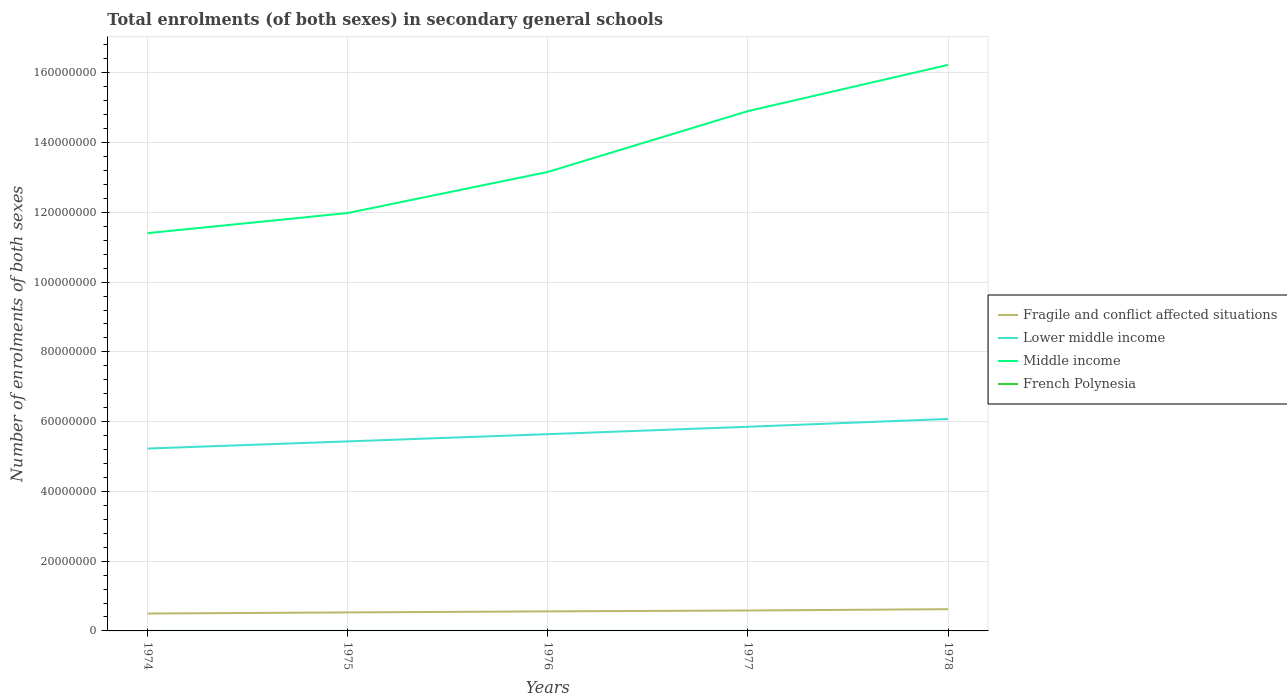Does the line corresponding to French Polynesia intersect with the line corresponding to Lower middle income?
Provide a short and direct response. No. Is the number of lines equal to the number of legend labels?
Your response must be concise. Yes. Across all years, what is the maximum number of enrolments in secondary schools in Middle income?
Keep it short and to the point. 1.14e+08. In which year was the number of enrolments in secondary schools in Fragile and conflict affected situations maximum?
Your response must be concise. 1974. What is the total number of enrolments in secondary schools in French Polynesia in the graph?
Provide a succinct answer. -234. What is the difference between the highest and the second highest number of enrolments in secondary schools in Lower middle income?
Provide a short and direct response. 8.49e+06. What is the difference between the highest and the lowest number of enrolments in secondary schools in Lower middle income?
Provide a succinct answer. 2. Is the number of enrolments in secondary schools in Middle income strictly greater than the number of enrolments in secondary schools in French Polynesia over the years?
Your response must be concise. No. How many lines are there?
Keep it short and to the point. 4. Are the values on the major ticks of Y-axis written in scientific E-notation?
Your response must be concise. No. Does the graph contain any zero values?
Ensure brevity in your answer.  No. Does the graph contain grids?
Provide a short and direct response. Yes. Where does the legend appear in the graph?
Offer a terse response. Center right. How many legend labels are there?
Ensure brevity in your answer.  4. What is the title of the graph?
Give a very brief answer. Total enrolments (of both sexes) in secondary general schools. Does "Korea (Democratic)" appear as one of the legend labels in the graph?
Offer a terse response. No. What is the label or title of the X-axis?
Give a very brief answer. Years. What is the label or title of the Y-axis?
Your answer should be compact. Number of enrolments of both sexes. What is the Number of enrolments of both sexes in Fragile and conflict affected situations in 1974?
Keep it short and to the point. 4.98e+06. What is the Number of enrolments of both sexes in Lower middle income in 1974?
Provide a succinct answer. 5.23e+07. What is the Number of enrolments of both sexes of Middle income in 1974?
Ensure brevity in your answer.  1.14e+08. What is the Number of enrolments of both sexes in French Polynesia in 1974?
Offer a terse response. 6597. What is the Number of enrolments of both sexes in Fragile and conflict affected situations in 1975?
Provide a short and direct response. 5.31e+06. What is the Number of enrolments of both sexes of Lower middle income in 1975?
Provide a short and direct response. 5.43e+07. What is the Number of enrolments of both sexes in Middle income in 1975?
Give a very brief answer. 1.20e+08. What is the Number of enrolments of both sexes of French Polynesia in 1975?
Make the answer very short. 7046. What is the Number of enrolments of both sexes in Fragile and conflict affected situations in 1976?
Offer a very short reply. 5.60e+06. What is the Number of enrolments of both sexes in Lower middle income in 1976?
Your response must be concise. 5.64e+07. What is the Number of enrolments of both sexes in Middle income in 1976?
Your answer should be compact. 1.32e+08. What is the Number of enrolments of both sexes of French Polynesia in 1976?
Give a very brief answer. 7280. What is the Number of enrolments of both sexes of Fragile and conflict affected situations in 1977?
Keep it short and to the point. 5.85e+06. What is the Number of enrolments of both sexes of Lower middle income in 1977?
Provide a short and direct response. 5.85e+07. What is the Number of enrolments of both sexes of Middle income in 1977?
Make the answer very short. 1.49e+08. What is the Number of enrolments of both sexes of French Polynesia in 1977?
Provide a succinct answer. 7727. What is the Number of enrolments of both sexes of Fragile and conflict affected situations in 1978?
Your answer should be compact. 6.23e+06. What is the Number of enrolments of both sexes in Lower middle income in 1978?
Offer a very short reply. 6.08e+07. What is the Number of enrolments of both sexes of Middle income in 1978?
Your answer should be very brief. 1.62e+08. What is the Number of enrolments of both sexes of French Polynesia in 1978?
Make the answer very short. 8047. Across all years, what is the maximum Number of enrolments of both sexes of Fragile and conflict affected situations?
Keep it short and to the point. 6.23e+06. Across all years, what is the maximum Number of enrolments of both sexes of Lower middle income?
Your answer should be very brief. 6.08e+07. Across all years, what is the maximum Number of enrolments of both sexes in Middle income?
Make the answer very short. 1.62e+08. Across all years, what is the maximum Number of enrolments of both sexes in French Polynesia?
Your answer should be compact. 8047. Across all years, what is the minimum Number of enrolments of both sexes in Fragile and conflict affected situations?
Keep it short and to the point. 4.98e+06. Across all years, what is the minimum Number of enrolments of both sexes of Lower middle income?
Offer a very short reply. 5.23e+07. Across all years, what is the minimum Number of enrolments of both sexes in Middle income?
Make the answer very short. 1.14e+08. Across all years, what is the minimum Number of enrolments of both sexes in French Polynesia?
Your response must be concise. 6597. What is the total Number of enrolments of both sexes in Fragile and conflict affected situations in the graph?
Offer a very short reply. 2.80e+07. What is the total Number of enrolments of both sexes in Lower middle income in the graph?
Ensure brevity in your answer.  2.82e+08. What is the total Number of enrolments of both sexes of Middle income in the graph?
Provide a short and direct response. 6.77e+08. What is the total Number of enrolments of both sexes of French Polynesia in the graph?
Give a very brief answer. 3.67e+04. What is the difference between the Number of enrolments of both sexes in Fragile and conflict affected situations in 1974 and that in 1975?
Give a very brief answer. -3.22e+05. What is the difference between the Number of enrolments of both sexes in Lower middle income in 1974 and that in 1975?
Provide a succinct answer. -2.05e+06. What is the difference between the Number of enrolments of both sexes of Middle income in 1974 and that in 1975?
Your answer should be very brief. -5.76e+06. What is the difference between the Number of enrolments of both sexes in French Polynesia in 1974 and that in 1975?
Ensure brevity in your answer.  -449. What is the difference between the Number of enrolments of both sexes in Fragile and conflict affected situations in 1974 and that in 1976?
Keep it short and to the point. -6.21e+05. What is the difference between the Number of enrolments of both sexes in Lower middle income in 1974 and that in 1976?
Your response must be concise. -4.12e+06. What is the difference between the Number of enrolments of both sexes in Middle income in 1974 and that in 1976?
Make the answer very short. -1.75e+07. What is the difference between the Number of enrolments of both sexes of French Polynesia in 1974 and that in 1976?
Your answer should be very brief. -683. What is the difference between the Number of enrolments of both sexes in Fragile and conflict affected situations in 1974 and that in 1977?
Offer a terse response. -8.71e+05. What is the difference between the Number of enrolments of both sexes in Lower middle income in 1974 and that in 1977?
Offer a terse response. -6.24e+06. What is the difference between the Number of enrolments of both sexes of Middle income in 1974 and that in 1977?
Offer a terse response. -3.50e+07. What is the difference between the Number of enrolments of both sexes of French Polynesia in 1974 and that in 1977?
Provide a short and direct response. -1130. What is the difference between the Number of enrolments of both sexes in Fragile and conflict affected situations in 1974 and that in 1978?
Make the answer very short. -1.25e+06. What is the difference between the Number of enrolments of both sexes in Lower middle income in 1974 and that in 1978?
Provide a short and direct response. -8.49e+06. What is the difference between the Number of enrolments of both sexes in Middle income in 1974 and that in 1978?
Offer a very short reply. -4.82e+07. What is the difference between the Number of enrolments of both sexes in French Polynesia in 1974 and that in 1978?
Ensure brevity in your answer.  -1450. What is the difference between the Number of enrolments of both sexes of Fragile and conflict affected situations in 1975 and that in 1976?
Your answer should be very brief. -2.99e+05. What is the difference between the Number of enrolments of both sexes in Lower middle income in 1975 and that in 1976?
Your answer should be very brief. -2.07e+06. What is the difference between the Number of enrolments of both sexes in Middle income in 1975 and that in 1976?
Provide a short and direct response. -1.18e+07. What is the difference between the Number of enrolments of both sexes of French Polynesia in 1975 and that in 1976?
Your answer should be compact. -234. What is the difference between the Number of enrolments of both sexes of Fragile and conflict affected situations in 1975 and that in 1977?
Ensure brevity in your answer.  -5.49e+05. What is the difference between the Number of enrolments of both sexes of Lower middle income in 1975 and that in 1977?
Ensure brevity in your answer.  -4.19e+06. What is the difference between the Number of enrolments of both sexes in Middle income in 1975 and that in 1977?
Provide a short and direct response. -2.92e+07. What is the difference between the Number of enrolments of both sexes of French Polynesia in 1975 and that in 1977?
Provide a succinct answer. -681. What is the difference between the Number of enrolments of both sexes in Fragile and conflict affected situations in 1975 and that in 1978?
Give a very brief answer. -9.24e+05. What is the difference between the Number of enrolments of both sexes of Lower middle income in 1975 and that in 1978?
Give a very brief answer. -6.44e+06. What is the difference between the Number of enrolments of both sexes of Middle income in 1975 and that in 1978?
Your answer should be very brief. -4.25e+07. What is the difference between the Number of enrolments of both sexes of French Polynesia in 1975 and that in 1978?
Your answer should be very brief. -1001. What is the difference between the Number of enrolments of both sexes in Fragile and conflict affected situations in 1976 and that in 1977?
Ensure brevity in your answer.  -2.49e+05. What is the difference between the Number of enrolments of both sexes of Lower middle income in 1976 and that in 1977?
Your response must be concise. -2.12e+06. What is the difference between the Number of enrolments of both sexes in Middle income in 1976 and that in 1977?
Ensure brevity in your answer.  -1.74e+07. What is the difference between the Number of enrolments of both sexes of French Polynesia in 1976 and that in 1977?
Offer a very short reply. -447. What is the difference between the Number of enrolments of both sexes of Fragile and conflict affected situations in 1976 and that in 1978?
Provide a succinct answer. -6.24e+05. What is the difference between the Number of enrolments of both sexes in Lower middle income in 1976 and that in 1978?
Provide a short and direct response. -4.37e+06. What is the difference between the Number of enrolments of both sexes of Middle income in 1976 and that in 1978?
Ensure brevity in your answer.  -3.07e+07. What is the difference between the Number of enrolments of both sexes in French Polynesia in 1976 and that in 1978?
Provide a short and direct response. -767. What is the difference between the Number of enrolments of both sexes in Fragile and conflict affected situations in 1977 and that in 1978?
Provide a succinct answer. -3.75e+05. What is the difference between the Number of enrolments of both sexes of Lower middle income in 1977 and that in 1978?
Provide a short and direct response. -2.25e+06. What is the difference between the Number of enrolments of both sexes in Middle income in 1977 and that in 1978?
Provide a succinct answer. -1.32e+07. What is the difference between the Number of enrolments of both sexes in French Polynesia in 1977 and that in 1978?
Ensure brevity in your answer.  -320. What is the difference between the Number of enrolments of both sexes of Fragile and conflict affected situations in 1974 and the Number of enrolments of both sexes of Lower middle income in 1975?
Provide a short and direct response. -4.94e+07. What is the difference between the Number of enrolments of both sexes in Fragile and conflict affected situations in 1974 and the Number of enrolments of both sexes in Middle income in 1975?
Offer a very short reply. -1.15e+08. What is the difference between the Number of enrolments of both sexes of Fragile and conflict affected situations in 1974 and the Number of enrolments of both sexes of French Polynesia in 1975?
Keep it short and to the point. 4.98e+06. What is the difference between the Number of enrolments of both sexes in Lower middle income in 1974 and the Number of enrolments of both sexes in Middle income in 1975?
Give a very brief answer. -6.75e+07. What is the difference between the Number of enrolments of both sexes of Lower middle income in 1974 and the Number of enrolments of both sexes of French Polynesia in 1975?
Offer a terse response. 5.23e+07. What is the difference between the Number of enrolments of both sexes of Middle income in 1974 and the Number of enrolments of both sexes of French Polynesia in 1975?
Provide a short and direct response. 1.14e+08. What is the difference between the Number of enrolments of both sexes in Fragile and conflict affected situations in 1974 and the Number of enrolments of both sexes in Lower middle income in 1976?
Your answer should be compact. -5.14e+07. What is the difference between the Number of enrolments of both sexes in Fragile and conflict affected situations in 1974 and the Number of enrolments of both sexes in Middle income in 1976?
Make the answer very short. -1.27e+08. What is the difference between the Number of enrolments of both sexes of Fragile and conflict affected situations in 1974 and the Number of enrolments of both sexes of French Polynesia in 1976?
Offer a terse response. 4.98e+06. What is the difference between the Number of enrolments of both sexes of Lower middle income in 1974 and the Number of enrolments of both sexes of Middle income in 1976?
Ensure brevity in your answer.  -7.93e+07. What is the difference between the Number of enrolments of both sexes in Lower middle income in 1974 and the Number of enrolments of both sexes in French Polynesia in 1976?
Keep it short and to the point. 5.23e+07. What is the difference between the Number of enrolments of both sexes in Middle income in 1974 and the Number of enrolments of both sexes in French Polynesia in 1976?
Provide a short and direct response. 1.14e+08. What is the difference between the Number of enrolments of both sexes of Fragile and conflict affected situations in 1974 and the Number of enrolments of both sexes of Lower middle income in 1977?
Provide a succinct answer. -5.35e+07. What is the difference between the Number of enrolments of both sexes in Fragile and conflict affected situations in 1974 and the Number of enrolments of both sexes in Middle income in 1977?
Give a very brief answer. -1.44e+08. What is the difference between the Number of enrolments of both sexes in Fragile and conflict affected situations in 1974 and the Number of enrolments of both sexes in French Polynesia in 1977?
Offer a terse response. 4.98e+06. What is the difference between the Number of enrolments of both sexes of Lower middle income in 1974 and the Number of enrolments of both sexes of Middle income in 1977?
Give a very brief answer. -9.67e+07. What is the difference between the Number of enrolments of both sexes in Lower middle income in 1974 and the Number of enrolments of both sexes in French Polynesia in 1977?
Give a very brief answer. 5.23e+07. What is the difference between the Number of enrolments of both sexes of Middle income in 1974 and the Number of enrolments of both sexes of French Polynesia in 1977?
Your answer should be compact. 1.14e+08. What is the difference between the Number of enrolments of both sexes of Fragile and conflict affected situations in 1974 and the Number of enrolments of both sexes of Lower middle income in 1978?
Your answer should be compact. -5.58e+07. What is the difference between the Number of enrolments of both sexes of Fragile and conflict affected situations in 1974 and the Number of enrolments of both sexes of Middle income in 1978?
Give a very brief answer. -1.57e+08. What is the difference between the Number of enrolments of both sexes of Fragile and conflict affected situations in 1974 and the Number of enrolments of both sexes of French Polynesia in 1978?
Offer a terse response. 4.98e+06. What is the difference between the Number of enrolments of both sexes in Lower middle income in 1974 and the Number of enrolments of both sexes in Middle income in 1978?
Provide a succinct answer. -1.10e+08. What is the difference between the Number of enrolments of both sexes of Lower middle income in 1974 and the Number of enrolments of both sexes of French Polynesia in 1978?
Provide a short and direct response. 5.23e+07. What is the difference between the Number of enrolments of both sexes of Middle income in 1974 and the Number of enrolments of both sexes of French Polynesia in 1978?
Give a very brief answer. 1.14e+08. What is the difference between the Number of enrolments of both sexes in Fragile and conflict affected situations in 1975 and the Number of enrolments of both sexes in Lower middle income in 1976?
Your answer should be very brief. -5.11e+07. What is the difference between the Number of enrolments of both sexes of Fragile and conflict affected situations in 1975 and the Number of enrolments of both sexes of Middle income in 1976?
Make the answer very short. -1.26e+08. What is the difference between the Number of enrolments of both sexes of Fragile and conflict affected situations in 1975 and the Number of enrolments of both sexes of French Polynesia in 1976?
Your response must be concise. 5.30e+06. What is the difference between the Number of enrolments of both sexes of Lower middle income in 1975 and the Number of enrolments of both sexes of Middle income in 1976?
Provide a short and direct response. -7.73e+07. What is the difference between the Number of enrolments of both sexes in Lower middle income in 1975 and the Number of enrolments of both sexes in French Polynesia in 1976?
Your answer should be compact. 5.43e+07. What is the difference between the Number of enrolments of both sexes of Middle income in 1975 and the Number of enrolments of both sexes of French Polynesia in 1976?
Provide a succinct answer. 1.20e+08. What is the difference between the Number of enrolments of both sexes in Fragile and conflict affected situations in 1975 and the Number of enrolments of both sexes in Lower middle income in 1977?
Offer a very short reply. -5.32e+07. What is the difference between the Number of enrolments of both sexes in Fragile and conflict affected situations in 1975 and the Number of enrolments of both sexes in Middle income in 1977?
Offer a terse response. -1.44e+08. What is the difference between the Number of enrolments of both sexes of Fragile and conflict affected situations in 1975 and the Number of enrolments of both sexes of French Polynesia in 1977?
Your answer should be compact. 5.30e+06. What is the difference between the Number of enrolments of both sexes in Lower middle income in 1975 and the Number of enrolments of both sexes in Middle income in 1977?
Give a very brief answer. -9.47e+07. What is the difference between the Number of enrolments of both sexes in Lower middle income in 1975 and the Number of enrolments of both sexes in French Polynesia in 1977?
Offer a very short reply. 5.43e+07. What is the difference between the Number of enrolments of both sexes of Middle income in 1975 and the Number of enrolments of both sexes of French Polynesia in 1977?
Make the answer very short. 1.20e+08. What is the difference between the Number of enrolments of both sexes in Fragile and conflict affected situations in 1975 and the Number of enrolments of both sexes in Lower middle income in 1978?
Provide a short and direct response. -5.55e+07. What is the difference between the Number of enrolments of both sexes in Fragile and conflict affected situations in 1975 and the Number of enrolments of both sexes in Middle income in 1978?
Offer a terse response. -1.57e+08. What is the difference between the Number of enrolments of both sexes of Fragile and conflict affected situations in 1975 and the Number of enrolments of both sexes of French Polynesia in 1978?
Offer a terse response. 5.30e+06. What is the difference between the Number of enrolments of both sexes of Lower middle income in 1975 and the Number of enrolments of both sexes of Middle income in 1978?
Your answer should be compact. -1.08e+08. What is the difference between the Number of enrolments of both sexes in Lower middle income in 1975 and the Number of enrolments of both sexes in French Polynesia in 1978?
Keep it short and to the point. 5.43e+07. What is the difference between the Number of enrolments of both sexes in Middle income in 1975 and the Number of enrolments of both sexes in French Polynesia in 1978?
Provide a short and direct response. 1.20e+08. What is the difference between the Number of enrolments of both sexes in Fragile and conflict affected situations in 1976 and the Number of enrolments of both sexes in Lower middle income in 1977?
Your response must be concise. -5.29e+07. What is the difference between the Number of enrolments of both sexes of Fragile and conflict affected situations in 1976 and the Number of enrolments of both sexes of Middle income in 1977?
Your answer should be compact. -1.43e+08. What is the difference between the Number of enrolments of both sexes of Fragile and conflict affected situations in 1976 and the Number of enrolments of both sexes of French Polynesia in 1977?
Provide a succinct answer. 5.60e+06. What is the difference between the Number of enrolments of both sexes in Lower middle income in 1976 and the Number of enrolments of both sexes in Middle income in 1977?
Give a very brief answer. -9.26e+07. What is the difference between the Number of enrolments of both sexes of Lower middle income in 1976 and the Number of enrolments of both sexes of French Polynesia in 1977?
Your response must be concise. 5.64e+07. What is the difference between the Number of enrolments of both sexes in Middle income in 1976 and the Number of enrolments of both sexes in French Polynesia in 1977?
Your response must be concise. 1.32e+08. What is the difference between the Number of enrolments of both sexes in Fragile and conflict affected situations in 1976 and the Number of enrolments of both sexes in Lower middle income in 1978?
Your response must be concise. -5.52e+07. What is the difference between the Number of enrolments of both sexes in Fragile and conflict affected situations in 1976 and the Number of enrolments of both sexes in Middle income in 1978?
Provide a short and direct response. -1.57e+08. What is the difference between the Number of enrolments of both sexes in Fragile and conflict affected situations in 1976 and the Number of enrolments of both sexes in French Polynesia in 1978?
Offer a terse response. 5.60e+06. What is the difference between the Number of enrolments of both sexes in Lower middle income in 1976 and the Number of enrolments of both sexes in Middle income in 1978?
Ensure brevity in your answer.  -1.06e+08. What is the difference between the Number of enrolments of both sexes of Lower middle income in 1976 and the Number of enrolments of both sexes of French Polynesia in 1978?
Give a very brief answer. 5.64e+07. What is the difference between the Number of enrolments of both sexes in Middle income in 1976 and the Number of enrolments of both sexes in French Polynesia in 1978?
Your answer should be very brief. 1.32e+08. What is the difference between the Number of enrolments of both sexes of Fragile and conflict affected situations in 1977 and the Number of enrolments of both sexes of Lower middle income in 1978?
Make the answer very short. -5.49e+07. What is the difference between the Number of enrolments of both sexes of Fragile and conflict affected situations in 1977 and the Number of enrolments of both sexes of Middle income in 1978?
Ensure brevity in your answer.  -1.56e+08. What is the difference between the Number of enrolments of both sexes in Fragile and conflict affected situations in 1977 and the Number of enrolments of both sexes in French Polynesia in 1978?
Offer a terse response. 5.85e+06. What is the difference between the Number of enrolments of both sexes in Lower middle income in 1977 and the Number of enrolments of both sexes in Middle income in 1978?
Provide a succinct answer. -1.04e+08. What is the difference between the Number of enrolments of both sexes of Lower middle income in 1977 and the Number of enrolments of both sexes of French Polynesia in 1978?
Make the answer very short. 5.85e+07. What is the difference between the Number of enrolments of both sexes of Middle income in 1977 and the Number of enrolments of both sexes of French Polynesia in 1978?
Ensure brevity in your answer.  1.49e+08. What is the average Number of enrolments of both sexes in Fragile and conflict affected situations per year?
Your answer should be compact. 5.60e+06. What is the average Number of enrolments of both sexes in Lower middle income per year?
Your answer should be compact. 5.65e+07. What is the average Number of enrolments of both sexes of Middle income per year?
Your answer should be very brief. 1.35e+08. What is the average Number of enrolments of both sexes in French Polynesia per year?
Keep it short and to the point. 7339.4. In the year 1974, what is the difference between the Number of enrolments of both sexes in Fragile and conflict affected situations and Number of enrolments of both sexes in Lower middle income?
Provide a succinct answer. -4.73e+07. In the year 1974, what is the difference between the Number of enrolments of both sexes of Fragile and conflict affected situations and Number of enrolments of both sexes of Middle income?
Provide a short and direct response. -1.09e+08. In the year 1974, what is the difference between the Number of enrolments of both sexes of Fragile and conflict affected situations and Number of enrolments of both sexes of French Polynesia?
Your answer should be very brief. 4.98e+06. In the year 1974, what is the difference between the Number of enrolments of both sexes in Lower middle income and Number of enrolments of both sexes in Middle income?
Keep it short and to the point. -6.18e+07. In the year 1974, what is the difference between the Number of enrolments of both sexes in Lower middle income and Number of enrolments of both sexes in French Polynesia?
Provide a succinct answer. 5.23e+07. In the year 1974, what is the difference between the Number of enrolments of both sexes in Middle income and Number of enrolments of both sexes in French Polynesia?
Offer a terse response. 1.14e+08. In the year 1975, what is the difference between the Number of enrolments of both sexes in Fragile and conflict affected situations and Number of enrolments of both sexes in Lower middle income?
Your answer should be compact. -4.90e+07. In the year 1975, what is the difference between the Number of enrolments of both sexes of Fragile and conflict affected situations and Number of enrolments of both sexes of Middle income?
Give a very brief answer. -1.15e+08. In the year 1975, what is the difference between the Number of enrolments of both sexes of Fragile and conflict affected situations and Number of enrolments of both sexes of French Polynesia?
Your answer should be compact. 5.30e+06. In the year 1975, what is the difference between the Number of enrolments of both sexes of Lower middle income and Number of enrolments of both sexes of Middle income?
Keep it short and to the point. -6.55e+07. In the year 1975, what is the difference between the Number of enrolments of both sexes of Lower middle income and Number of enrolments of both sexes of French Polynesia?
Make the answer very short. 5.43e+07. In the year 1975, what is the difference between the Number of enrolments of both sexes of Middle income and Number of enrolments of both sexes of French Polynesia?
Offer a very short reply. 1.20e+08. In the year 1976, what is the difference between the Number of enrolments of both sexes of Fragile and conflict affected situations and Number of enrolments of both sexes of Lower middle income?
Your response must be concise. -5.08e+07. In the year 1976, what is the difference between the Number of enrolments of both sexes in Fragile and conflict affected situations and Number of enrolments of both sexes in Middle income?
Offer a terse response. -1.26e+08. In the year 1976, what is the difference between the Number of enrolments of both sexes in Fragile and conflict affected situations and Number of enrolments of both sexes in French Polynesia?
Offer a terse response. 5.60e+06. In the year 1976, what is the difference between the Number of enrolments of both sexes in Lower middle income and Number of enrolments of both sexes in Middle income?
Provide a succinct answer. -7.52e+07. In the year 1976, what is the difference between the Number of enrolments of both sexes in Lower middle income and Number of enrolments of both sexes in French Polynesia?
Your answer should be compact. 5.64e+07. In the year 1976, what is the difference between the Number of enrolments of both sexes in Middle income and Number of enrolments of both sexes in French Polynesia?
Keep it short and to the point. 1.32e+08. In the year 1977, what is the difference between the Number of enrolments of both sexes of Fragile and conflict affected situations and Number of enrolments of both sexes of Lower middle income?
Provide a short and direct response. -5.27e+07. In the year 1977, what is the difference between the Number of enrolments of both sexes of Fragile and conflict affected situations and Number of enrolments of both sexes of Middle income?
Your answer should be very brief. -1.43e+08. In the year 1977, what is the difference between the Number of enrolments of both sexes in Fragile and conflict affected situations and Number of enrolments of both sexes in French Polynesia?
Offer a very short reply. 5.85e+06. In the year 1977, what is the difference between the Number of enrolments of both sexes of Lower middle income and Number of enrolments of both sexes of Middle income?
Your answer should be very brief. -9.05e+07. In the year 1977, what is the difference between the Number of enrolments of both sexes in Lower middle income and Number of enrolments of both sexes in French Polynesia?
Make the answer very short. 5.85e+07. In the year 1977, what is the difference between the Number of enrolments of both sexes in Middle income and Number of enrolments of both sexes in French Polynesia?
Ensure brevity in your answer.  1.49e+08. In the year 1978, what is the difference between the Number of enrolments of both sexes of Fragile and conflict affected situations and Number of enrolments of both sexes of Lower middle income?
Ensure brevity in your answer.  -5.45e+07. In the year 1978, what is the difference between the Number of enrolments of both sexes in Fragile and conflict affected situations and Number of enrolments of both sexes in Middle income?
Offer a very short reply. -1.56e+08. In the year 1978, what is the difference between the Number of enrolments of both sexes in Fragile and conflict affected situations and Number of enrolments of both sexes in French Polynesia?
Your answer should be very brief. 6.22e+06. In the year 1978, what is the difference between the Number of enrolments of both sexes in Lower middle income and Number of enrolments of both sexes in Middle income?
Ensure brevity in your answer.  -1.02e+08. In the year 1978, what is the difference between the Number of enrolments of both sexes of Lower middle income and Number of enrolments of both sexes of French Polynesia?
Your answer should be very brief. 6.08e+07. In the year 1978, what is the difference between the Number of enrolments of both sexes in Middle income and Number of enrolments of both sexes in French Polynesia?
Your response must be concise. 1.62e+08. What is the ratio of the Number of enrolments of both sexes of Fragile and conflict affected situations in 1974 to that in 1975?
Provide a succinct answer. 0.94. What is the ratio of the Number of enrolments of both sexes of Lower middle income in 1974 to that in 1975?
Offer a very short reply. 0.96. What is the ratio of the Number of enrolments of both sexes in Middle income in 1974 to that in 1975?
Make the answer very short. 0.95. What is the ratio of the Number of enrolments of both sexes in French Polynesia in 1974 to that in 1975?
Offer a terse response. 0.94. What is the ratio of the Number of enrolments of both sexes of Fragile and conflict affected situations in 1974 to that in 1976?
Provide a short and direct response. 0.89. What is the ratio of the Number of enrolments of both sexes in Lower middle income in 1974 to that in 1976?
Your response must be concise. 0.93. What is the ratio of the Number of enrolments of both sexes in Middle income in 1974 to that in 1976?
Give a very brief answer. 0.87. What is the ratio of the Number of enrolments of both sexes in French Polynesia in 1974 to that in 1976?
Your answer should be very brief. 0.91. What is the ratio of the Number of enrolments of both sexes in Fragile and conflict affected situations in 1974 to that in 1977?
Make the answer very short. 0.85. What is the ratio of the Number of enrolments of both sexes in Lower middle income in 1974 to that in 1977?
Your answer should be compact. 0.89. What is the ratio of the Number of enrolments of both sexes of Middle income in 1974 to that in 1977?
Keep it short and to the point. 0.77. What is the ratio of the Number of enrolments of both sexes of French Polynesia in 1974 to that in 1977?
Offer a very short reply. 0.85. What is the ratio of the Number of enrolments of both sexes of Lower middle income in 1974 to that in 1978?
Ensure brevity in your answer.  0.86. What is the ratio of the Number of enrolments of both sexes in Middle income in 1974 to that in 1978?
Offer a very short reply. 0.7. What is the ratio of the Number of enrolments of both sexes of French Polynesia in 1974 to that in 1978?
Provide a short and direct response. 0.82. What is the ratio of the Number of enrolments of both sexes in Fragile and conflict affected situations in 1975 to that in 1976?
Keep it short and to the point. 0.95. What is the ratio of the Number of enrolments of both sexes of Lower middle income in 1975 to that in 1976?
Your answer should be very brief. 0.96. What is the ratio of the Number of enrolments of both sexes in Middle income in 1975 to that in 1976?
Give a very brief answer. 0.91. What is the ratio of the Number of enrolments of both sexes of French Polynesia in 1975 to that in 1976?
Provide a succinct answer. 0.97. What is the ratio of the Number of enrolments of both sexes in Fragile and conflict affected situations in 1975 to that in 1977?
Make the answer very short. 0.91. What is the ratio of the Number of enrolments of both sexes in Lower middle income in 1975 to that in 1977?
Provide a succinct answer. 0.93. What is the ratio of the Number of enrolments of both sexes of Middle income in 1975 to that in 1977?
Give a very brief answer. 0.8. What is the ratio of the Number of enrolments of both sexes of French Polynesia in 1975 to that in 1977?
Provide a succinct answer. 0.91. What is the ratio of the Number of enrolments of both sexes of Fragile and conflict affected situations in 1975 to that in 1978?
Provide a short and direct response. 0.85. What is the ratio of the Number of enrolments of both sexes of Lower middle income in 1975 to that in 1978?
Make the answer very short. 0.89. What is the ratio of the Number of enrolments of both sexes in Middle income in 1975 to that in 1978?
Keep it short and to the point. 0.74. What is the ratio of the Number of enrolments of both sexes in French Polynesia in 1975 to that in 1978?
Offer a very short reply. 0.88. What is the ratio of the Number of enrolments of both sexes in Fragile and conflict affected situations in 1976 to that in 1977?
Keep it short and to the point. 0.96. What is the ratio of the Number of enrolments of both sexes of Lower middle income in 1976 to that in 1977?
Your answer should be very brief. 0.96. What is the ratio of the Number of enrolments of both sexes in Middle income in 1976 to that in 1977?
Your response must be concise. 0.88. What is the ratio of the Number of enrolments of both sexes in French Polynesia in 1976 to that in 1977?
Your response must be concise. 0.94. What is the ratio of the Number of enrolments of both sexes of Fragile and conflict affected situations in 1976 to that in 1978?
Provide a short and direct response. 0.9. What is the ratio of the Number of enrolments of both sexes of Lower middle income in 1976 to that in 1978?
Your answer should be compact. 0.93. What is the ratio of the Number of enrolments of both sexes of Middle income in 1976 to that in 1978?
Provide a short and direct response. 0.81. What is the ratio of the Number of enrolments of both sexes of French Polynesia in 1976 to that in 1978?
Offer a terse response. 0.9. What is the ratio of the Number of enrolments of both sexes of Fragile and conflict affected situations in 1977 to that in 1978?
Make the answer very short. 0.94. What is the ratio of the Number of enrolments of both sexes in Lower middle income in 1977 to that in 1978?
Ensure brevity in your answer.  0.96. What is the ratio of the Number of enrolments of both sexes in Middle income in 1977 to that in 1978?
Offer a terse response. 0.92. What is the ratio of the Number of enrolments of both sexes in French Polynesia in 1977 to that in 1978?
Your response must be concise. 0.96. What is the difference between the highest and the second highest Number of enrolments of both sexes of Fragile and conflict affected situations?
Give a very brief answer. 3.75e+05. What is the difference between the highest and the second highest Number of enrolments of both sexes in Lower middle income?
Keep it short and to the point. 2.25e+06. What is the difference between the highest and the second highest Number of enrolments of both sexes in Middle income?
Ensure brevity in your answer.  1.32e+07. What is the difference between the highest and the second highest Number of enrolments of both sexes of French Polynesia?
Your answer should be compact. 320. What is the difference between the highest and the lowest Number of enrolments of both sexes in Fragile and conflict affected situations?
Provide a succinct answer. 1.25e+06. What is the difference between the highest and the lowest Number of enrolments of both sexes of Lower middle income?
Offer a terse response. 8.49e+06. What is the difference between the highest and the lowest Number of enrolments of both sexes in Middle income?
Offer a very short reply. 4.82e+07. What is the difference between the highest and the lowest Number of enrolments of both sexes in French Polynesia?
Make the answer very short. 1450. 